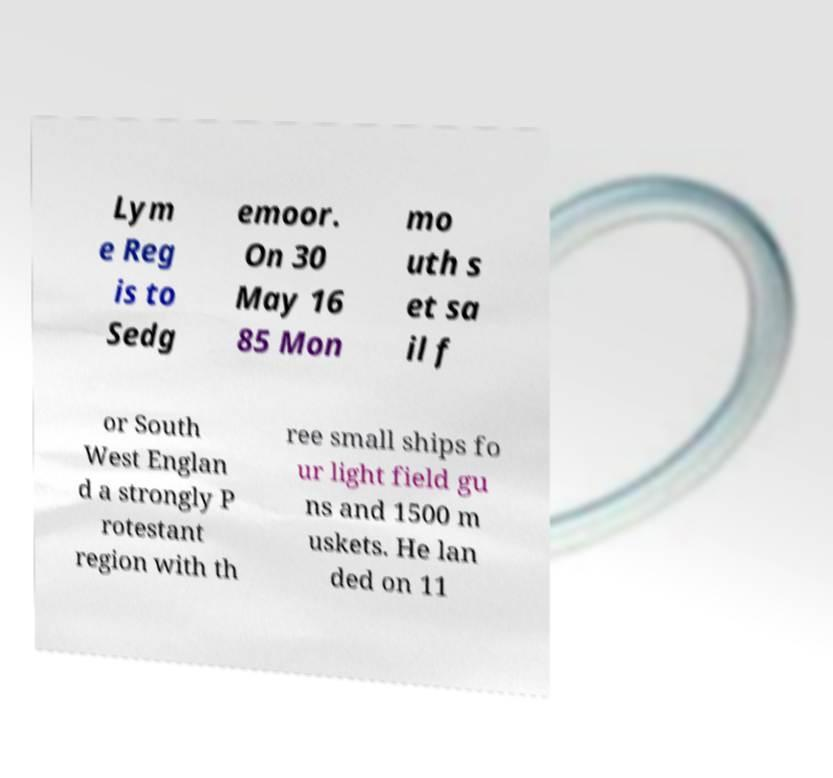Please identify and transcribe the text found in this image. Lym e Reg is to Sedg emoor. On 30 May 16 85 Mon mo uth s et sa il f or South West Englan d a strongly P rotestant region with th ree small ships fo ur light field gu ns and 1500 m uskets. He lan ded on 11 